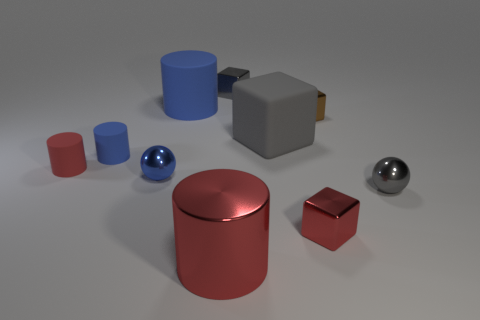Are there fewer cylinders behind the blue shiny sphere than tiny shiny spheres that are on the right side of the large blue cylinder?
Provide a succinct answer. No. What number of tiny blue things are made of the same material as the big gray thing?
Your answer should be very brief. 1. There is a gray rubber thing; does it have the same size as the red metal object that is on the left side of the tiny gray metal cube?
Provide a short and direct response. Yes. What material is the other small cylinder that is the same color as the metallic cylinder?
Your response must be concise. Rubber. There is a red cylinder to the right of the blue matte cylinder that is behind the big matte object on the right side of the big red metal thing; how big is it?
Your response must be concise. Large. Are there more small gray objects that are behind the big matte cylinder than big things that are on the left side of the small blue metal ball?
Provide a short and direct response. Yes. There is a tiny block in front of the gray sphere; how many shiny balls are left of it?
Offer a terse response. 1. Are there any small metallic spheres of the same color as the large block?
Your answer should be very brief. Yes. Is the gray shiny cube the same size as the blue metal ball?
Your answer should be compact. Yes. The tiny red thing that is left of the big cylinder that is behind the small blue cylinder is made of what material?
Your answer should be compact. Rubber. 